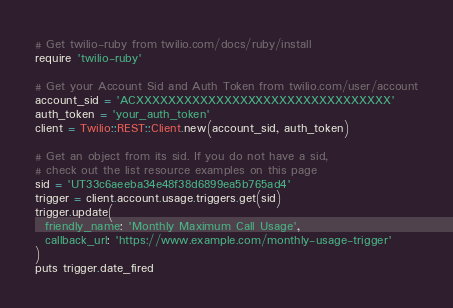<code> <loc_0><loc_0><loc_500><loc_500><_Ruby_># Get twilio-ruby from twilio.com/docs/ruby/install
require 'twilio-ruby'

# Get your Account Sid and Auth Token from twilio.com/user/account
account_sid = 'ACXXXXXXXXXXXXXXXXXXXXXXXXXXXXXXXX'
auth_token = 'your_auth_token'
client = Twilio::REST::Client.new(account_sid, auth_token)

# Get an object from its sid. If you do not have a sid,
# check out the list resource examples on this page
sid = 'UT33c6aeeba34e48f38d6899ea5b765ad4'
trigger = client.account.usage.triggers.get(sid)
trigger.update(
  friendly_name: 'Monthly Maximum Call Usage',
  callback_url: 'https://www.example.com/monthly-usage-trigger'
)
puts trigger.date_fired
</code> 